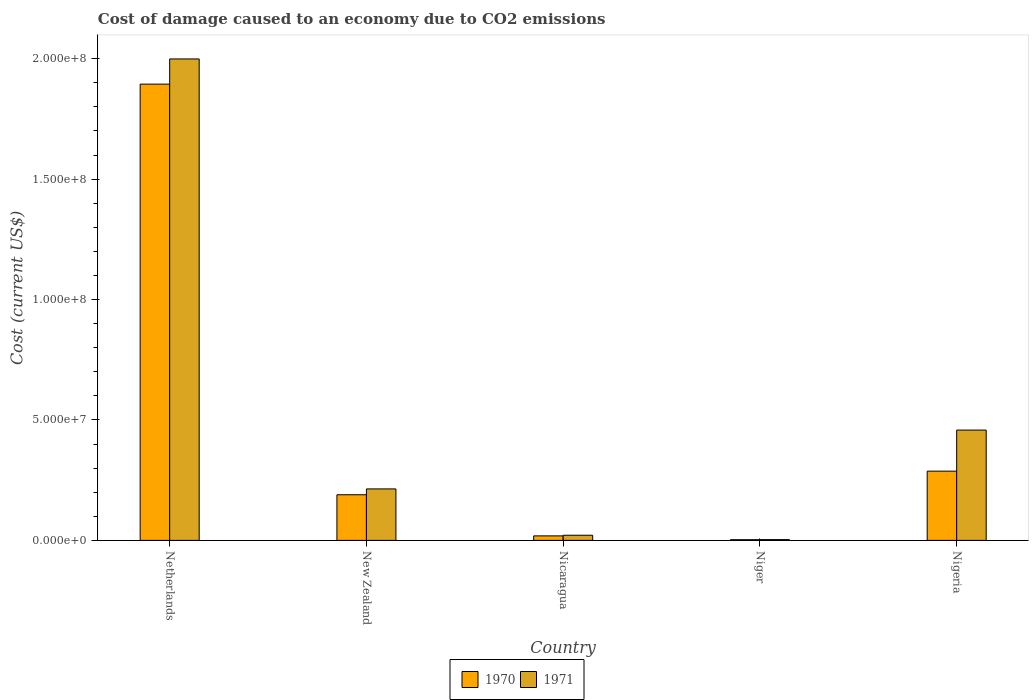How many bars are there on the 4th tick from the left?
Provide a short and direct response. 2. How many bars are there on the 5th tick from the right?
Offer a very short reply. 2. What is the label of the 4th group of bars from the left?
Ensure brevity in your answer.  Niger. What is the cost of damage caused due to CO2 emissisons in 1971 in New Zealand?
Give a very brief answer. 2.14e+07. Across all countries, what is the maximum cost of damage caused due to CO2 emissisons in 1971?
Make the answer very short. 2.00e+08. Across all countries, what is the minimum cost of damage caused due to CO2 emissisons in 1971?
Your response must be concise. 3.28e+05. In which country was the cost of damage caused due to CO2 emissisons in 1970 minimum?
Ensure brevity in your answer.  Niger. What is the total cost of damage caused due to CO2 emissisons in 1970 in the graph?
Ensure brevity in your answer.  2.39e+08. What is the difference between the cost of damage caused due to CO2 emissisons in 1971 in Netherlands and that in Nicaragua?
Your response must be concise. 1.98e+08. What is the difference between the cost of damage caused due to CO2 emissisons in 1971 in Netherlands and the cost of damage caused due to CO2 emissisons in 1970 in Niger?
Keep it short and to the point. 2.00e+08. What is the average cost of damage caused due to CO2 emissisons in 1971 per country?
Provide a short and direct response. 5.39e+07. What is the difference between the cost of damage caused due to CO2 emissisons of/in 1971 and cost of damage caused due to CO2 emissisons of/in 1970 in Netherlands?
Your response must be concise. 1.05e+07. In how many countries, is the cost of damage caused due to CO2 emissisons in 1971 greater than 120000000 US$?
Provide a succinct answer. 1. What is the ratio of the cost of damage caused due to CO2 emissisons in 1971 in Netherlands to that in Niger?
Provide a succinct answer. 609.79. Is the cost of damage caused due to CO2 emissisons in 1970 in Niger less than that in Nigeria?
Make the answer very short. Yes. What is the difference between the highest and the second highest cost of damage caused due to CO2 emissisons in 1970?
Ensure brevity in your answer.  1.61e+08. What is the difference between the highest and the lowest cost of damage caused due to CO2 emissisons in 1970?
Give a very brief answer. 1.89e+08. What does the 1st bar from the right in Nigeria represents?
Offer a very short reply. 1971. What is the difference between two consecutive major ticks on the Y-axis?
Offer a terse response. 5.00e+07. Does the graph contain any zero values?
Your answer should be compact. No. Does the graph contain grids?
Your answer should be compact. No. What is the title of the graph?
Ensure brevity in your answer.  Cost of damage caused to an economy due to CO2 emissions. What is the label or title of the X-axis?
Give a very brief answer. Country. What is the label or title of the Y-axis?
Keep it short and to the point. Cost (current US$). What is the Cost (current US$) of 1970 in Netherlands?
Offer a terse response. 1.89e+08. What is the Cost (current US$) of 1971 in Netherlands?
Ensure brevity in your answer.  2.00e+08. What is the Cost (current US$) in 1970 in New Zealand?
Keep it short and to the point. 1.89e+07. What is the Cost (current US$) in 1971 in New Zealand?
Ensure brevity in your answer.  2.14e+07. What is the Cost (current US$) of 1970 in Nicaragua?
Your response must be concise. 1.87e+06. What is the Cost (current US$) in 1971 in Nicaragua?
Your response must be concise. 2.14e+06. What is the Cost (current US$) of 1970 in Niger?
Provide a succinct answer. 2.89e+05. What is the Cost (current US$) of 1971 in Niger?
Ensure brevity in your answer.  3.28e+05. What is the Cost (current US$) of 1970 in Nigeria?
Provide a succinct answer. 2.88e+07. What is the Cost (current US$) in 1971 in Nigeria?
Keep it short and to the point. 4.58e+07. Across all countries, what is the maximum Cost (current US$) of 1970?
Provide a short and direct response. 1.89e+08. Across all countries, what is the maximum Cost (current US$) in 1971?
Make the answer very short. 2.00e+08. Across all countries, what is the minimum Cost (current US$) of 1970?
Your response must be concise. 2.89e+05. Across all countries, what is the minimum Cost (current US$) of 1971?
Offer a terse response. 3.28e+05. What is the total Cost (current US$) in 1970 in the graph?
Your response must be concise. 2.39e+08. What is the total Cost (current US$) of 1971 in the graph?
Offer a terse response. 2.70e+08. What is the difference between the Cost (current US$) of 1970 in Netherlands and that in New Zealand?
Provide a short and direct response. 1.71e+08. What is the difference between the Cost (current US$) of 1971 in Netherlands and that in New Zealand?
Provide a short and direct response. 1.79e+08. What is the difference between the Cost (current US$) in 1970 in Netherlands and that in Nicaragua?
Your answer should be very brief. 1.88e+08. What is the difference between the Cost (current US$) in 1971 in Netherlands and that in Nicaragua?
Make the answer very short. 1.98e+08. What is the difference between the Cost (current US$) of 1970 in Netherlands and that in Niger?
Your answer should be very brief. 1.89e+08. What is the difference between the Cost (current US$) in 1971 in Netherlands and that in Niger?
Ensure brevity in your answer.  2.00e+08. What is the difference between the Cost (current US$) of 1970 in Netherlands and that in Nigeria?
Make the answer very short. 1.61e+08. What is the difference between the Cost (current US$) of 1971 in Netherlands and that in Nigeria?
Give a very brief answer. 1.54e+08. What is the difference between the Cost (current US$) of 1970 in New Zealand and that in Nicaragua?
Offer a terse response. 1.71e+07. What is the difference between the Cost (current US$) in 1971 in New Zealand and that in Nicaragua?
Give a very brief answer. 1.92e+07. What is the difference between the Cost (current US$) of 1970 in New Zealand and that in Niger?
Make the answer very short. 1.87e+07. What is the difference between the Cost (current US$) in 1971 in New Zealand and that in Niger?
Your answer should be compact. 2.10e+07. What is the difference between the Cost (current US$) in 1970 in New Zealand and that in Nigeria?
Your answer should be compact. -9.80e+06. What is the difference between the Cost (current US$) in 1971 in New Zealand and that in Nigeria?
Your response must be concise. -2.44e+07. What is the difference between the Cost (current US$) of 1970 in Nicaragua and that in Niger?
Ensure brevity in your answer.  1.59e+06. What is the difference between the Cost (current US$) of 1971 in Nicaragua and that in Niger?
Provide a succinct answer. 1.81e+06. What is the difference between the Cost (current US$) in 1970 in Nicaragua and that in Nigeria?
Your answer should be compact. -2.69e+07. What is the difference between the Cost (current US$) in 1971 in Nicaragua and that in Nigeria?
Keep it short and to the point. -4.37e+07. What is the difference between the Cost (current US$) in 1970 in Niger and that in Nigeria?
Give a very brief answer. -2.85e+07. What is the difference between the Cost (current US$) in 1971 in Niger and that in Nigeria?
Keep it short and to the point. -4.55e+07. What is the difference between the Cost (current US$) of 1970 in Netherlands and the Cost (current US$) of 1971 in New Zealand?
Provide a succinct answer. 1.68e+08. What is the difference between the Cost (current US$) of 1970 in Netherlands and the Cost (current US$) of 1971 in Nicaragua?
Ensure brevity in your answer.  1.87e+08. What is the difference between the Cost (current US$) of 1970 in Netherlands and the Cost (current US$) of 1971 in Niger?
Your response must be concise. 1.89e+08. What is the difference between the Cost (current US$) of 1970 in Netherlands and the Cost (current US$) of 1971 in Nigeria?
Ensure brevity in your answer.  1.44e+08. What is the difference between the Cost (current US$) of 1970 in New Zealand and the Cost (current US$) of 1971 in Nicaragua?
Make the answer very short. 1.68e+07. What is the difference between the Cost (current US$) in 1970 in New Zealand and the Cost (current US$) in 1971 in Niger?
Offer a very short reply. 1.86e+07. What is the difference between the Cost (current US$) in 1970 in New Zealand and the Cost (current US$) in 1971 in Nigeria?
Provide a short and direct response. -2.69e+07. What is the difference between the Cost (current US$) of 1970 in Nicaragua and the Cost (current US$) of 1971 in Niger?
Offer a terse response. 1.55e+06. What is the difference between the Cost (current US$) of 1970 in Nicaragua and the Cost (current US$) of 1971 in Nigeria?
Offer a terse response. -4.39e+07. What is the difference between the Cost (current US$) in 1970 in Niger and the Cost (current US$) in 1971 in Nigeria?
Offer a very short reply. -4.55e+07. What is the average Cost (current US$) in 1970 per country?
Provide a short and direct response. 4.79e+07. What is the average Cost (current US$) of 1971 per country?
Offer a terse response. 5.39e+07. What is the difference between the Cost (current US$) of 1970 and Cost (current US$) of 1971 in Netherlands?
Your answer should be compact. -1.05e+07. What is the difference between the Cost (current US$) in 1970 and Cost (current US$) in 1971 in New Zealand?
Provide a succinct answer. -2.42e+06. What is the difference between the Cost (current US$) in 1970 and Cost (current US$) in 1971 in Nicaragua?
Your response must be concise. -2.64e+05. What is the difference between the Cost (current US$) of 1970 and Cost (current US$) of 1971 in Niger?
Ensure brevity in your answer.  -3.90e+04. What is the difference between the Cost (current US$) in 1970 and Cost (current US$) in 1971 in Nigeria?
Give a very brief answer. -1.71e+07. What is the ratio of the Cost (current US$) in 1970 in Netherlands to that in New Zealand?
Ensure brevity in your answer.  10. What is the ratio of the Cost (current US$) of 1971 in Netherlands to that in New Zealand?
Your answer should be compact. 9.35. What is the ratio of the Cost (current US$) in 1970 in Netherlands to that in Nicaragua?
Your response must be concise. 101.06. What is the ratio of the Cost (current US$) in 1971 in Netherlands to that in Nicaragua?
Make the answer very short. 93.47. What is the ratio of the Cost (current US$) in 1970 in Netherlands to that in Niger?
Offer a very short reply. 656.03. What is the ratio of the Cost (current US$) in 1971 in Netherlands to that in Niger?
Provide a succinct answer. 609.79. What is the ratio of the Cost (current US$) in 1970 in Netherlands to that in Nigeria?
Your answer should be compact. 6.59. What is the ratio of the Cost (current US$) of 1971 in Netherlands to that in Nigeria?
Provide a succinct answer. 4.36. What is the ratio of the Cost (current US$) of 1970 in New Zealand to that in Nicaragua?
Your response must be concise. 10.11. What is the ratio of the Cost (current US$) in 1971 in New Zealand to that in Nicaragua?
Keep it short and to the point. 9.99. What is the ratio of the Cost (current US$) of 1970 in New Zealand to that in Niger?
Offer a terse response. 65.61. What is the ratio of the Cost (current US$) of 1971 in New Zealand to that in Niger?
Your answer should be very brief. 65.19. What is the ratio of the Cost (current US$) in 1970 in New Zealand to that in Nigeria?
Provide a succinct answer. 0.66. What is the ratio of the Cost (current US$) in 1971 in New Zealand to that in Nigeria?
Provide a succinct answer. 0.47. What is the ratio of the Cost (current US$) of 1970 in Nicaragua to that in Niger?
Your answer should be compact. 6.49. What is the ratio of the Cost (current US$) in 1971 in Nicaragua to that in Niger?
Your answer should be compact. 6.52. What is the ratio of the Cost (current US$) of 1970 in Nicaragua to that in Nigeria?
Your response must be concise. 0.07. What is the ratio of the Cost (current US$) in 1971 in Nicaragua to that in Nigeria?
Offer a very short reply. 0.05. What is the ratio of the Cost (current US$) of 1971 in Niger to that in Nigeria?
Keep it short and to the point. 0.01. What is the difference between the highest and the second highest Cost (current US$) in 1970?
Offer a terse response. 1.61e+08. What is the difference between the highest and the second highest Cost (current US$) in 1971?
Ensure brevity in your answer.  1.54e+08. What is the difference between the highest and the lowest Cost (current US$) of 1970?
Keep it short and to the point. 1.89e+08. What is the difference between the highest and the lowest Cost (current US$) in 1971?
Provide a succinct answer. 2.00e+08. 